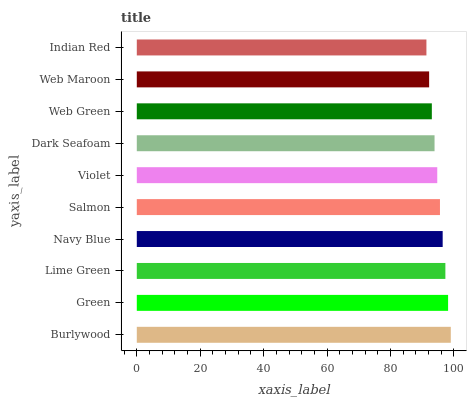Is Indian Red the minimum?
Answer yes or no. Yes. Is Burlywood the maximum?
Answer yes or no. Yes. Is Green the minimum?
Answer yes or no. No. Is Green the maximum?
Answer yes or no. No. Is Burlywood greater than Green?
Answer yes or no. Yes. Is Green less than Burlywood?
Answer yes or no. Yes. Is Green greater than Burlywood?
Answer yes or no. No. Is Burlywood less than Green?
Answer yes or no. No. Is Salmon the high median?
Answer yes or no. Yes. Is Violet the low median?
Answer yes or no. Yes. Is Web Maroon the high median?
Answer yes or no. No. Is Web Green the low median?
Answer yes or no. No. 